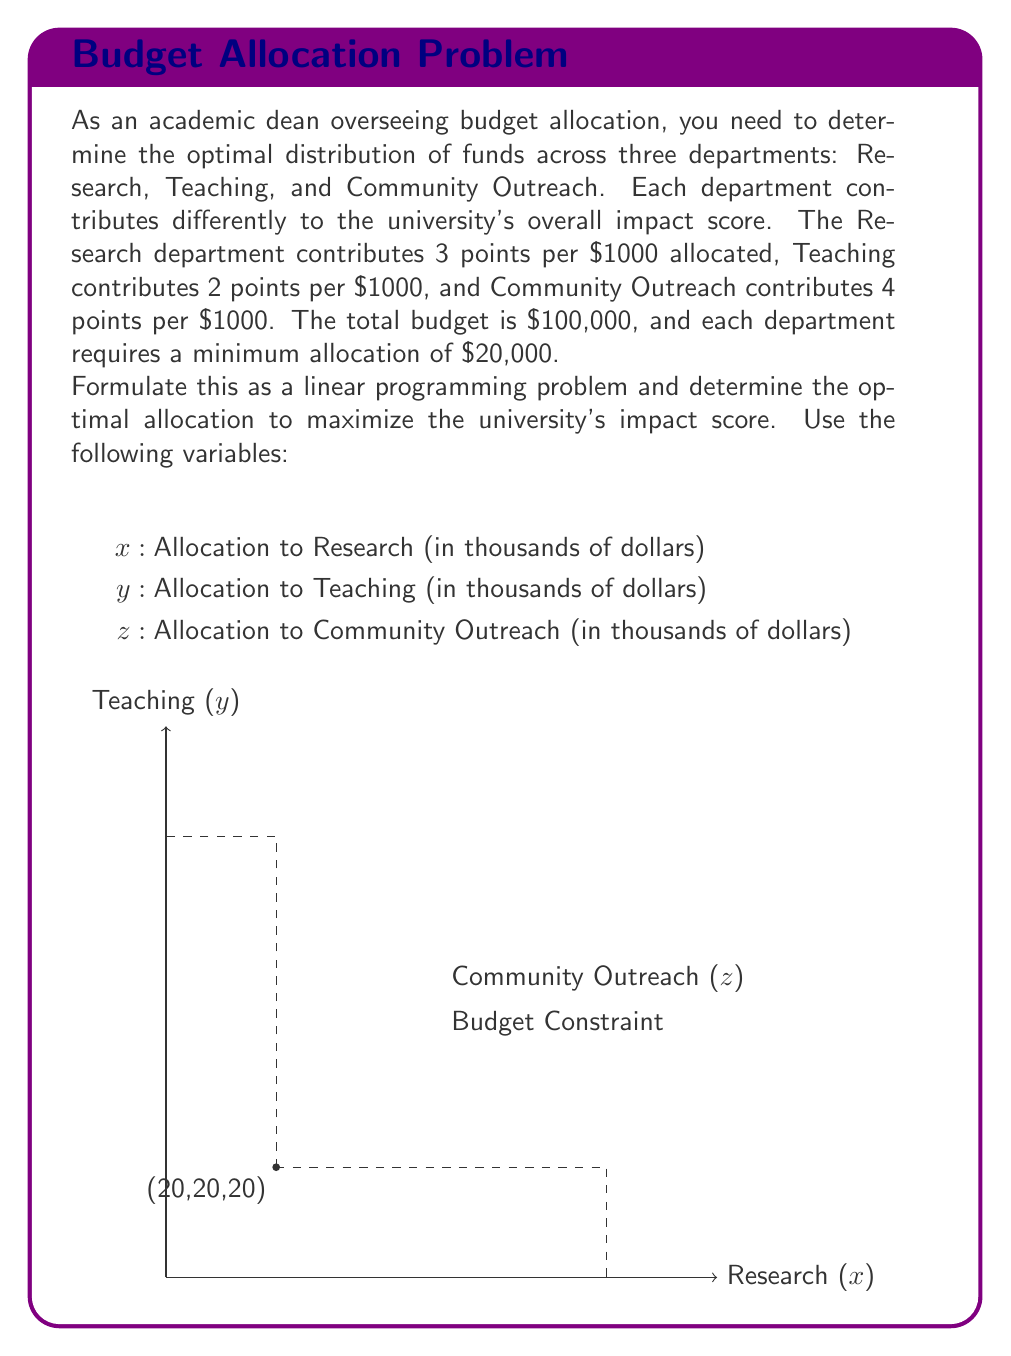Give your solution to this math problem. Let's approach this step-by-step:

1) Objective function: We want to maximize the impact score
   $$ \text{Maximize } Z = 3x + 2y + 4z $$

2) Constraints:
   a) Total budget constraint: $x + y + z = 100$ (remember, x, y, z are in thousands)
   b) Minimum allocation constraints:
      $x \geq 20$
      $y \geq 20$
      $z \geq 20$

3) Non-negativity constraints:
   $x, y, z \geq 0$

4) To solve this, we can use the simplex method or graphical method. Given the simplicity, let's use the graphical method.

5) The feasible region is a triangle on the plane $x + y + z = 100$, bounded by the lines $x = 20$, $y = 20$, and $z = 20$.

6) The optimal solution will be at one of the vertices of this triangle. The vertices are:
   (20, 20, 60), (20, 60, 20), and (60, 20, 20)

7) Let's evaluate the objective function at each point:
   At (20, 20, 60): $3(20) + 2(20) + 4(60) = 60 + 40 + 240 = 340$
   At (20, 60, 20): $3(20) + 2(60) + 4(20) = 60 + 120 + 80 = 260$
   At (60, 20, 20): $3(60) + 2(20) + 4(20) = 180 + 40 + 80 = 300$

8) The maximum value is 340, which occurs at the point (20, 20, 60).
Answer: Optimal allocation: Research $20,000, Teaching $20,000, Community Outreach $60,000. Maximum impact score: 340. 